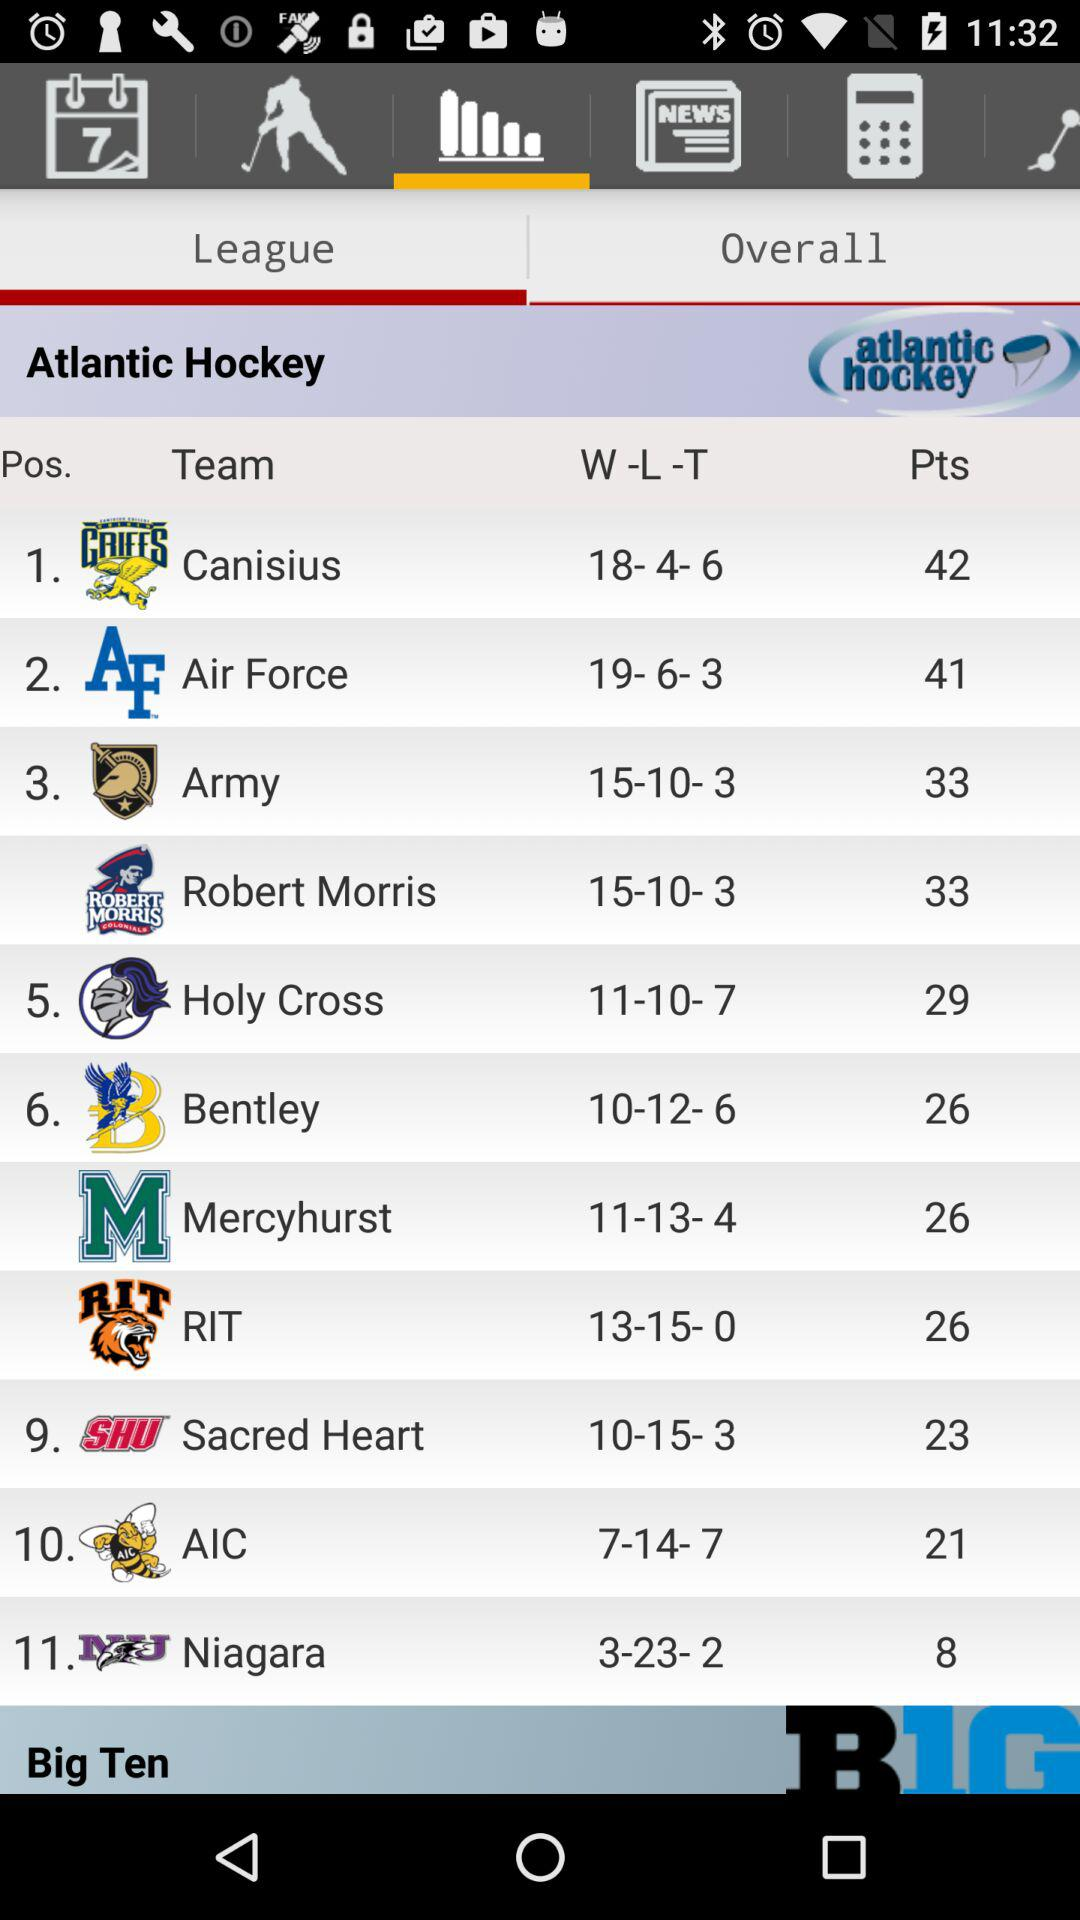Which team is in the first position? The team, Canisius, is in the first position. 